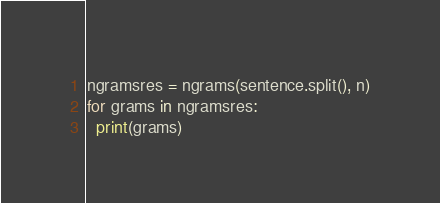<code> <loc_0><loc_0><loc_500><loc_500><_Python_>ngramsres = ngrams(sentence.split(), n)
for grams in ngramsres:
  print(grams)

</code> 